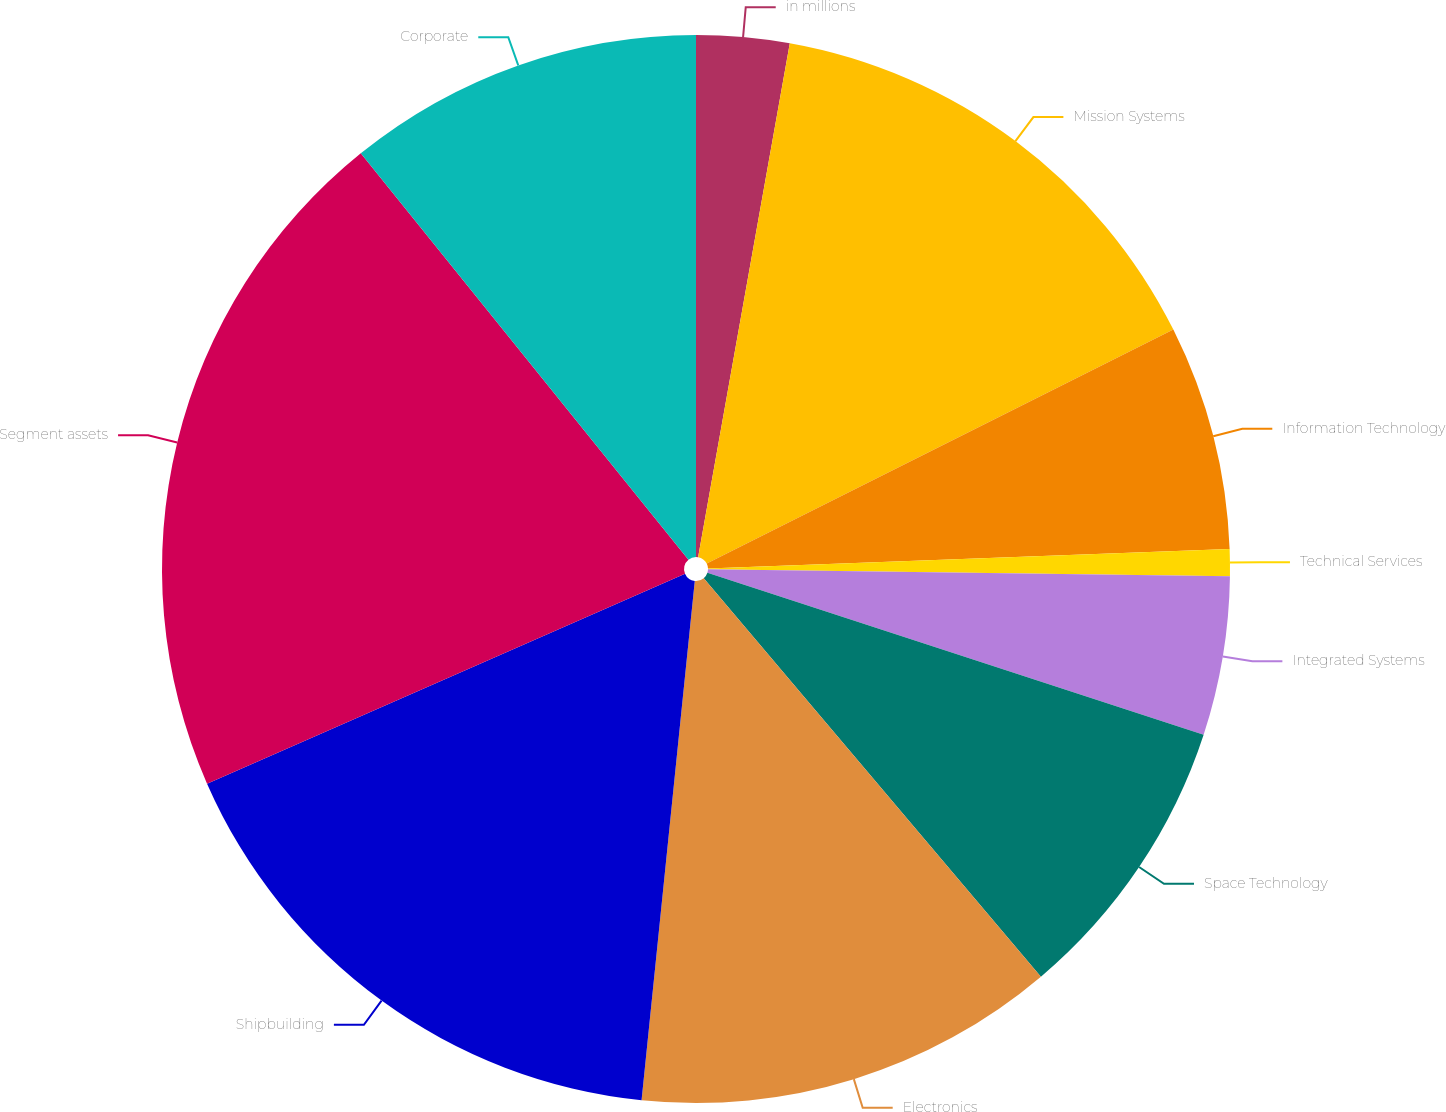Convert chart to OTSL. <chart><loc_0><loc_0><loc_500><loc_500><pie_chart><fcel>in millions<fcel>Mission Systems<fcel>Information Technology<fcel>Technical Services<fcel>Integrated Systems<fcel>Space Technology<fcel>Electronics<fcel>Shipbuilding<fcel>Segment assets<fcel>Corporate<nl><fcel>2.81%<fcel>14.79%<fcel>6.8%<fcel>0.81%<fcel>4.81%<fcel>8.8%<fcel>12.8%<fcel>16.79%<fcel>20.78%<fcel>10.8%<nl></chart> 